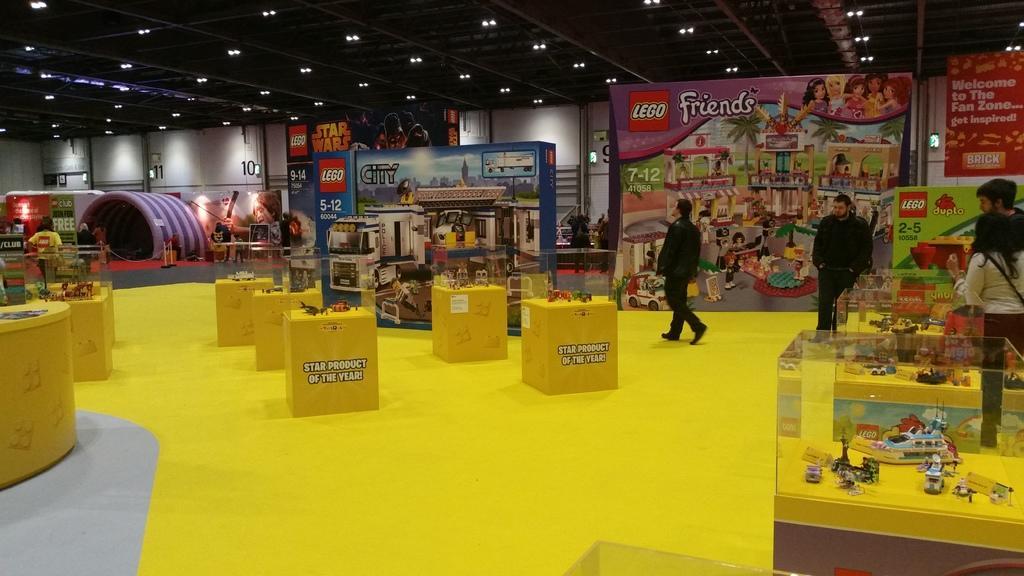Describe this image in one or two sentences. In this image we can see a group of toys on the tables which are placed on the floor. We can also see some people standing beside them. On the backside we can see some boards with the pictures and text on it, a tent, poles tied with ropes, lights, a wall with some numbers on it and a roof with some ceiling lights. 